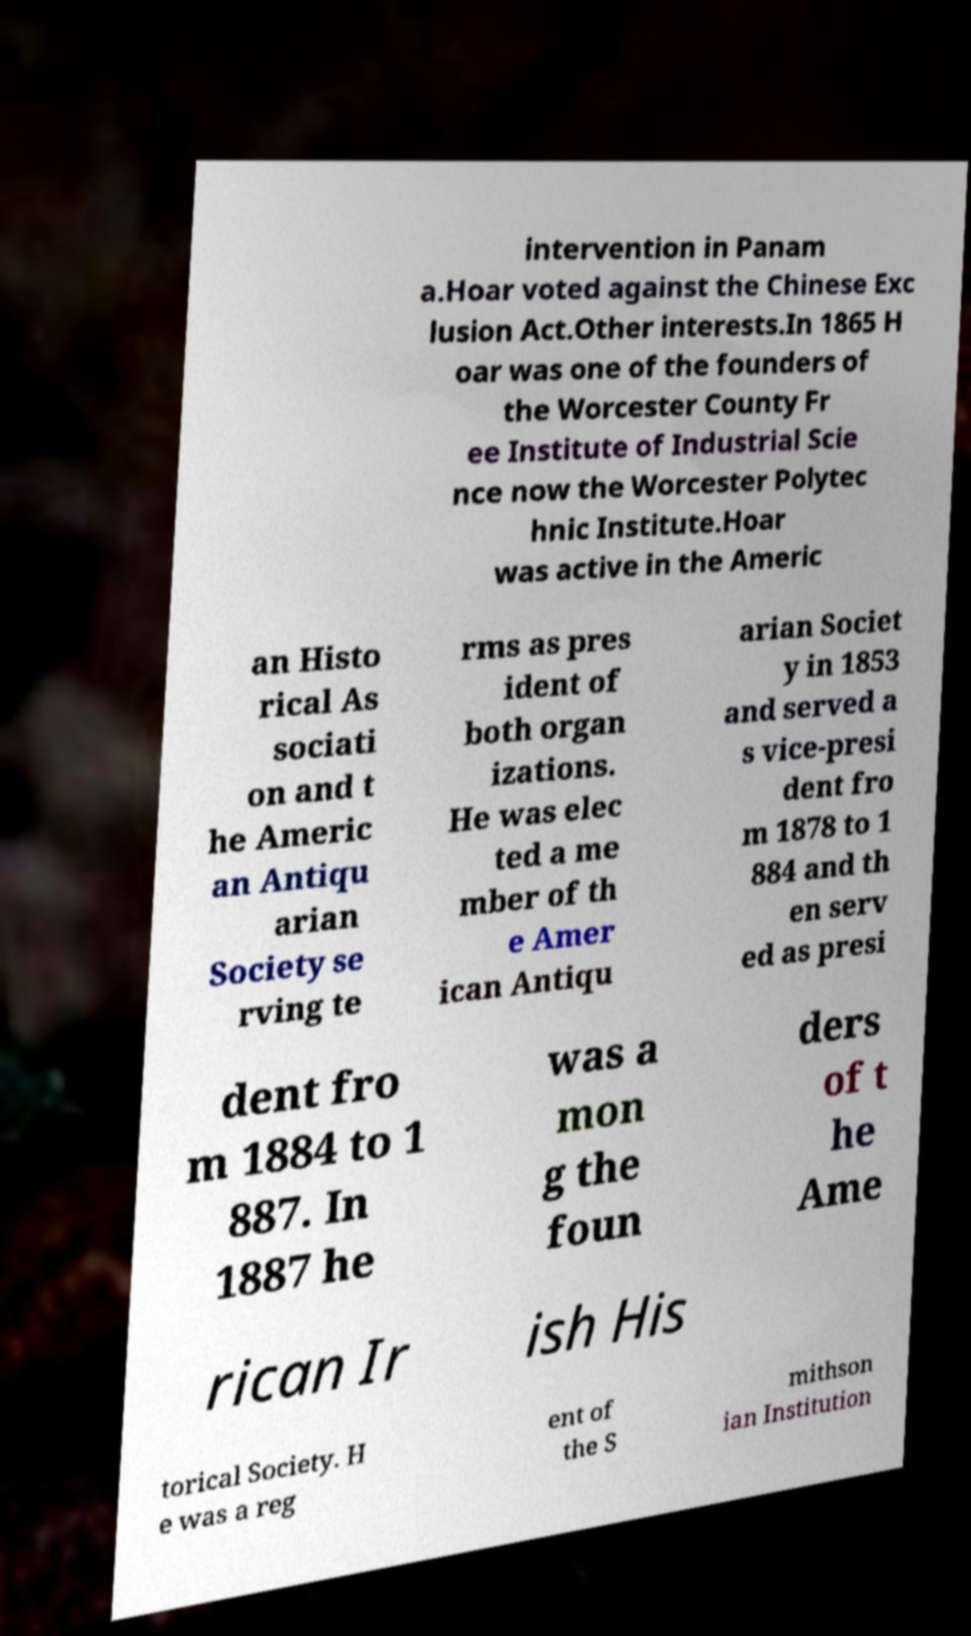Can you accurately transcribe the text from the provided image for me? intervention in Panam a.Hoar voted against the Chinese Exc lusion Act.Other interests.In 1865 H oar was one of the founders of the Worcester County Fr ee Institute of Industrial Scie nce now the Worcester Polytec hnic Institute.Hoar was active in the Americ an Histo rical As sociati on and t he Americ an Antiqu arian Society se rving te rms as pres ident of both organ izations. He was elec ted a me mber of th e Amer ican Antiqu arian Societ y in 1853 and served a s vice-presi dent fro m 1878 to 1 884 and th en serv ed as presi dent fro m 1884 to 1 887. In 1887 he was a mon g the foun ders of t he Ame rican Ir ish His torical Society. H e was a reg ent of the S mithson ian Institution 